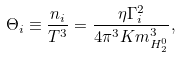Convert formula to latex. <formula><loc_0><loc_0><loc_500><loc_500>\Theta _ { i } \equiv \frac { n _ { i } } { T ^ { 3 } } = \frac { \eta \Gamma _ { i } ^ { 2 } } { 4 \pi ^ { 3 } K m ^ { 3 } _ { H ^ { 0 } _ { 2 } } } ,</formula> 